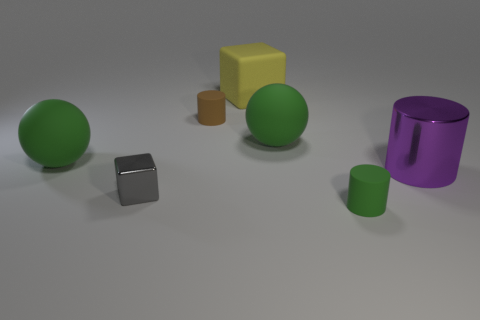Is there a pattern in how the objects are arranged? The objects seem to be arranged in no particular pattern; they are scattered across the surface with varying distances between them. The diversity in color, size, and placement creates a visually interesting assortment without a discernible pattern. 